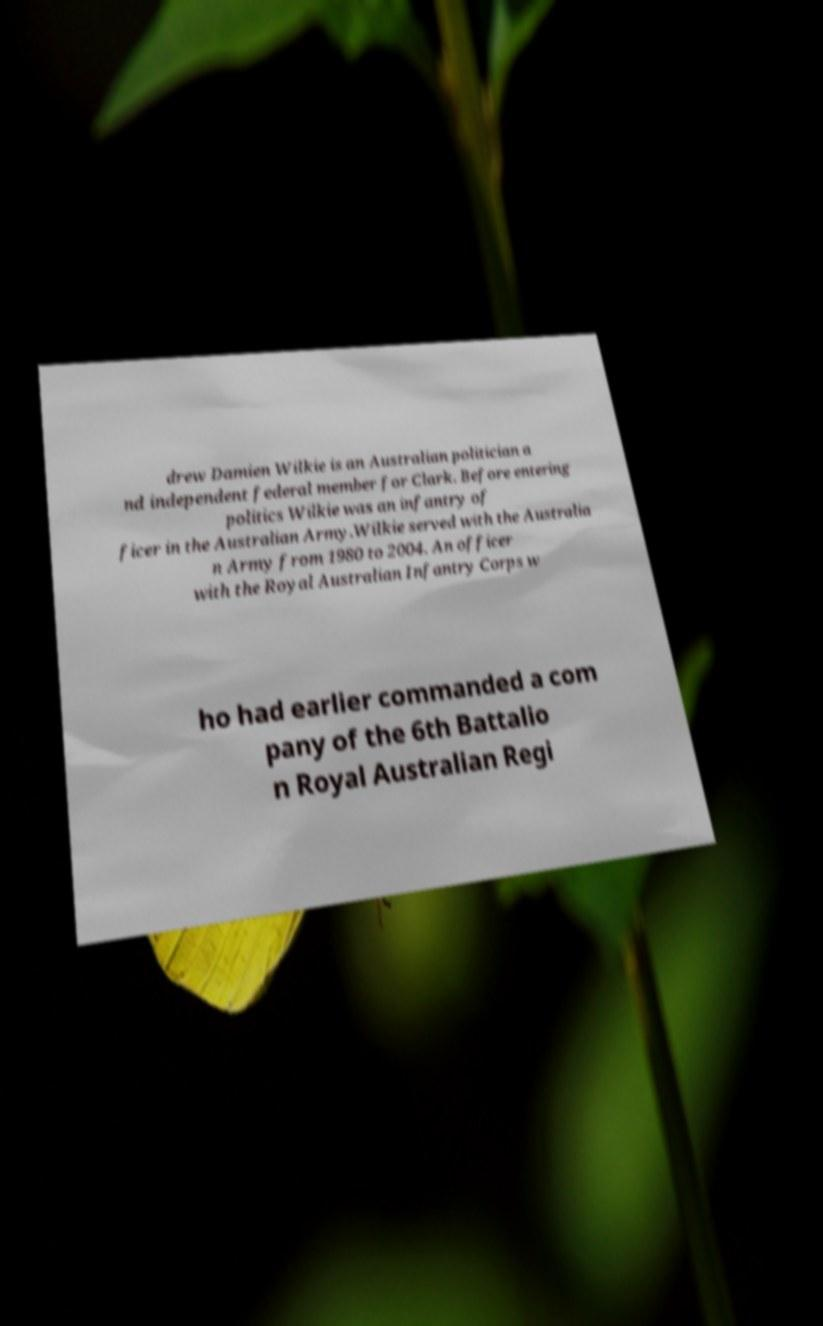Could you assist in decoding the text presented in this image and type it out clearly? drew Damien Wilkie is an Australian politician a nd independent federal member for Clark. Before entering politics Wilkie was an infantry of ficer in the Australian Army.Wilkie served with the Australia n Army from 1980 to 2004. An officer with the Royal Australian Infantry Corps w ho had earlier commanded a com pany of the 6th Battalio n Royal Australian Regi 